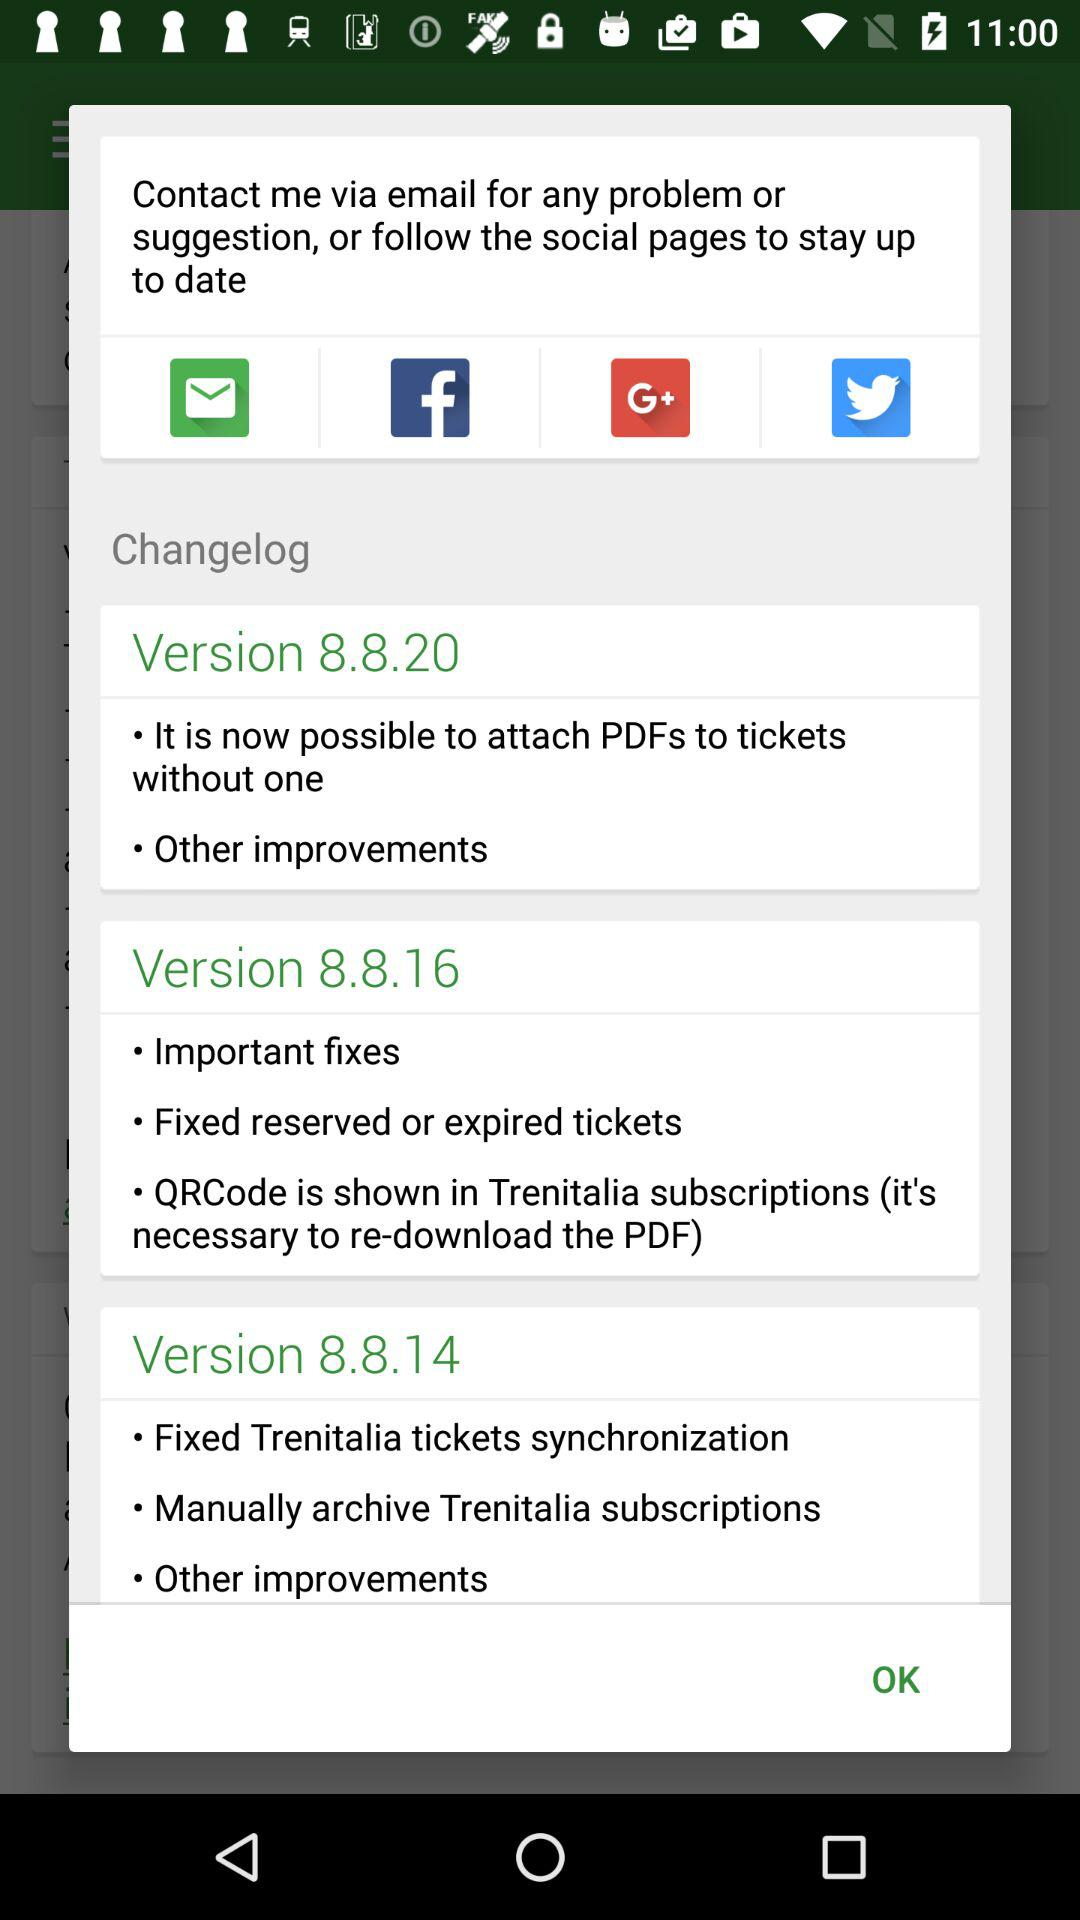What is new about version 8.8.14? The new improvements are "Fixed Trenitalia tickets synchronization", "Manually archive Trenitalia subscriptions" and "Other improvements". 